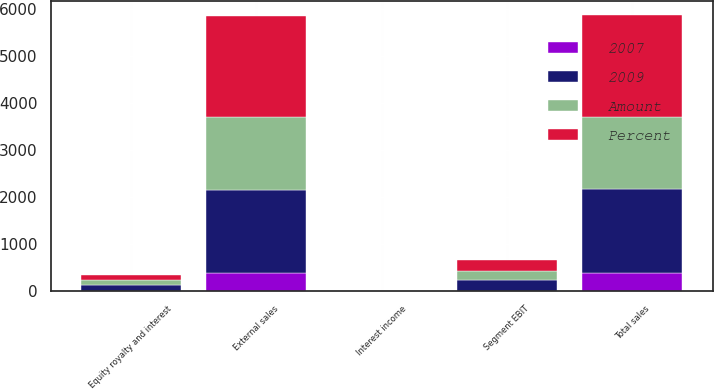<chart> <loc_0><loc_0><loc_500><loc_500><stacked_bar_chart><ecel><fcel>External sales<fcel>Total sales<fcel>Equity royalty and interest<fcel>Interest income<fcel>Segment EBIT<nl><fcel>2009<fcel>1777<fcel>1784<fcel>125<fcel>1<fcel>235<nl><fcel>Percent<fcel>2155<fcel>2164<fcel>117<fcel>2<fcel>242<nl><fcel>Amount<fcel>1537<fcel>1540<fcel>92<fcel>1<fcel>187<nl><fcel>2007<fcel>378<fcel>380<fcel>8<fcel>1<fcel>7<nl></chart> 